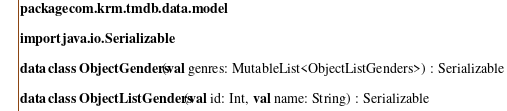<code> <loc_0><loc_0><loc_500><loc_500><_Kotlin_>package com.krm.tmdb.data.model

import java.io.Serializable

data class ObjectGenders(val genres: MutableList<ObjectListGenders>) : Serializable

data class ObjectListGenders(val id: Int, val name: String) : Serializable</code> 